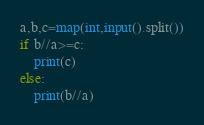<code> <loc_0><loc_0><loc_500><loc_500><_Python_>a,b,c=map(int,input().split())
if b//a>=c:
    print(c)
else:
    print(b//a)



</code> 